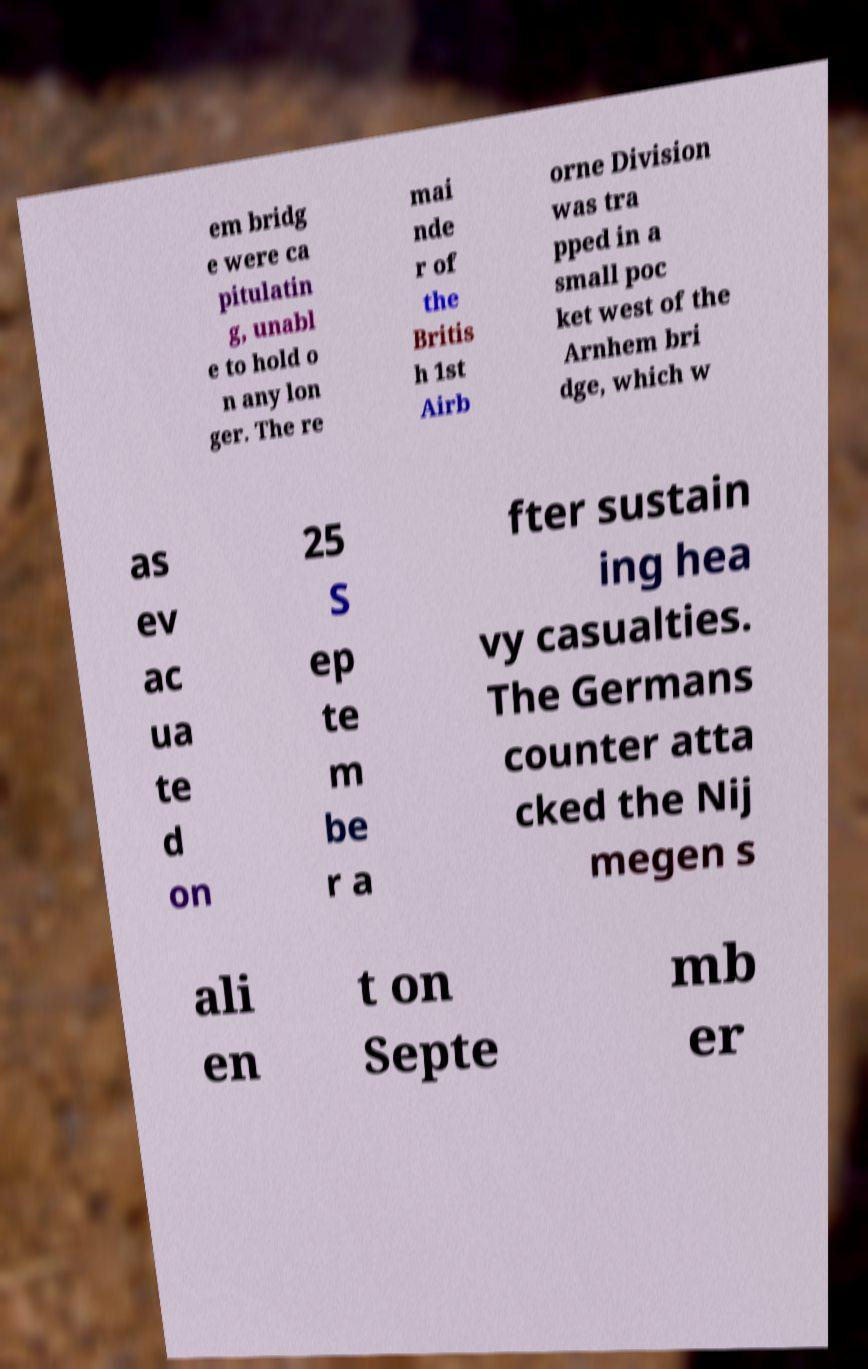For documentation purposes, I need the text within this image transcribed. Could you provide that? em bridg e were ca pitulatin g, unabl e to hold o n any lon ger. The re mai nde r of the Britis h 1st Airb orne Division was tra pped in a small poc ket west of the Arnhem bri dge, which w as ev ac ua te d on 25 S ep te m be r a fter sustain ing hea vy casualties. The Germans counter atta cked the Nij megen s ali en t on Septe mb er 